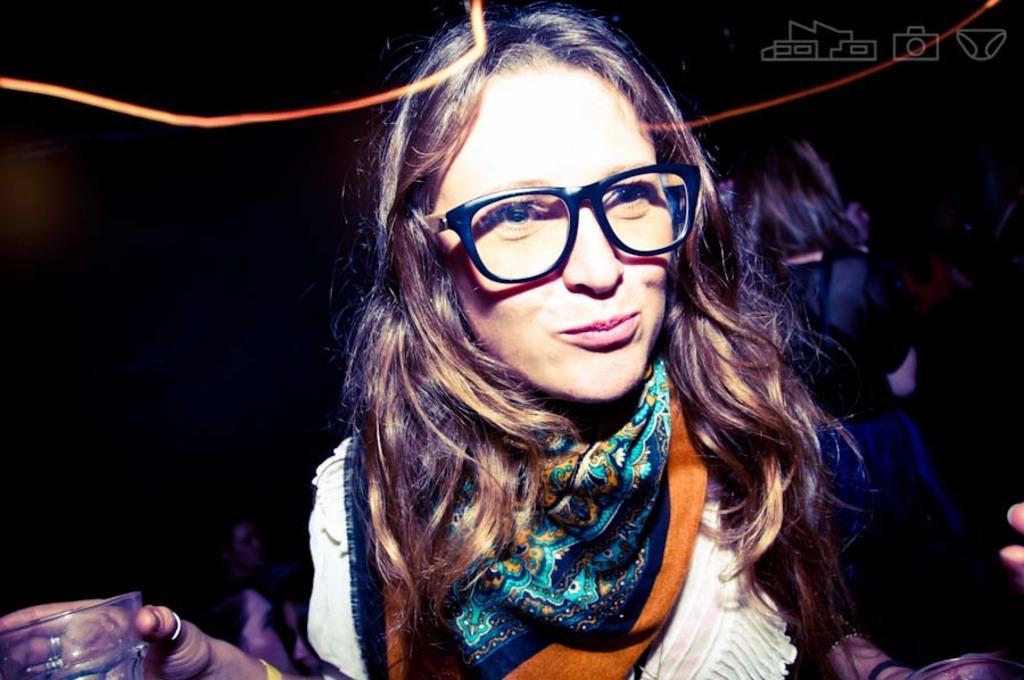Could you give a brief overview of what you see in this image? In the center of the image we can see a person is standing and she is wearing glasses. And we can see she is holding one object. On the right side of the image, we can see a few people. At the top right side of the image, there is a watermark. And we can see the dark background. 